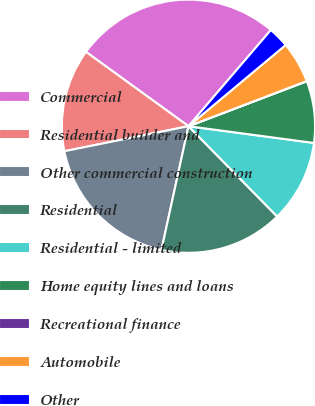Convert chart. <chart><loc_0><loc_0><loc_500><loc_500><pie_chart><fcel>Commercial<fcel>Residential builder and<fcel>Other commercial construction<fcel>Residential<fcel>Residential - limited<fcel>Home equity lines and loans<fcel>Recreational finance<fcel>Automobile<fcel>Other<nl><fcel>26.29%<fcel>13.15%<fcel>18.41%<fcel>15.78%<fcel>10.53%<fcel>7.9%<fcel>0.02%<fcel>5.27%<fcel>2.65%<nl></chart> 